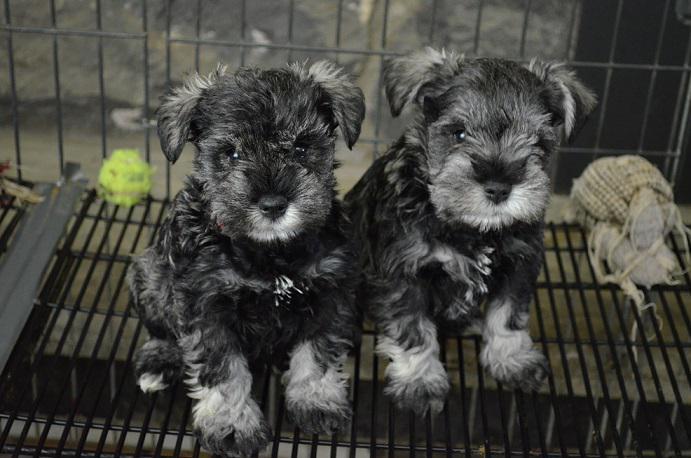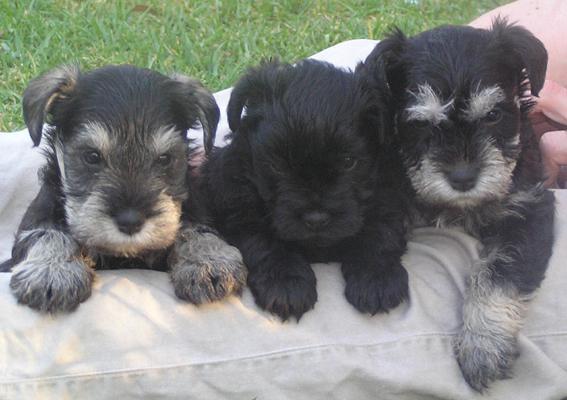The first image is the image on the left, the second image is the image on the right. For the images displayed, is the sentence "There are at least three dogs in the right image." factually correct? Answer yes or no. Yes. The first image is the image on the left, the second image is the image on the right. Examine the images to the left and right. Is the description "All dogs are schnauzer puppies, and at least some dogs have white eyebrows." accurate? Answer yes or no. Yes. 